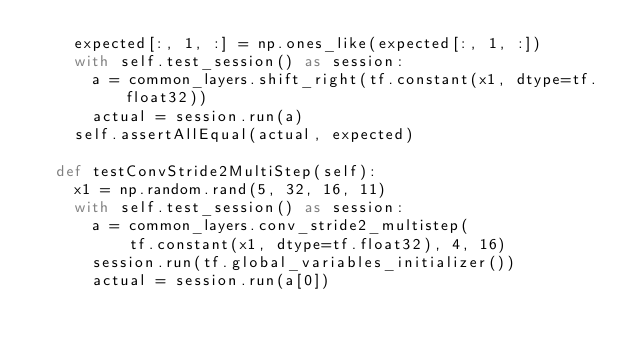<code> <loc_0><loc_0><loc_500><loc_500><_Python_>    expected[:, 1, :] = np.ones_like(expected[:, 1, :])
    with self.test_session() as session:
      a = common_layers.shift_right(tf.constant(x1, dtype=tf.float32))
      actual = session.run(a)
    self.assertAllEqual(actual, expected)

  def testConvStride2MultiStep(self):
    x1 = np.random.rand(5, 32, 16, 11)
    with self.test_session() as session:
      a = common_layers.conv_stride2_multistep(
          tf.constant(x1, dtype=tf.float32), 4, 16)
      session.run(tf.global_variables_initializer())
      actual = session.run(a[0])</code> 